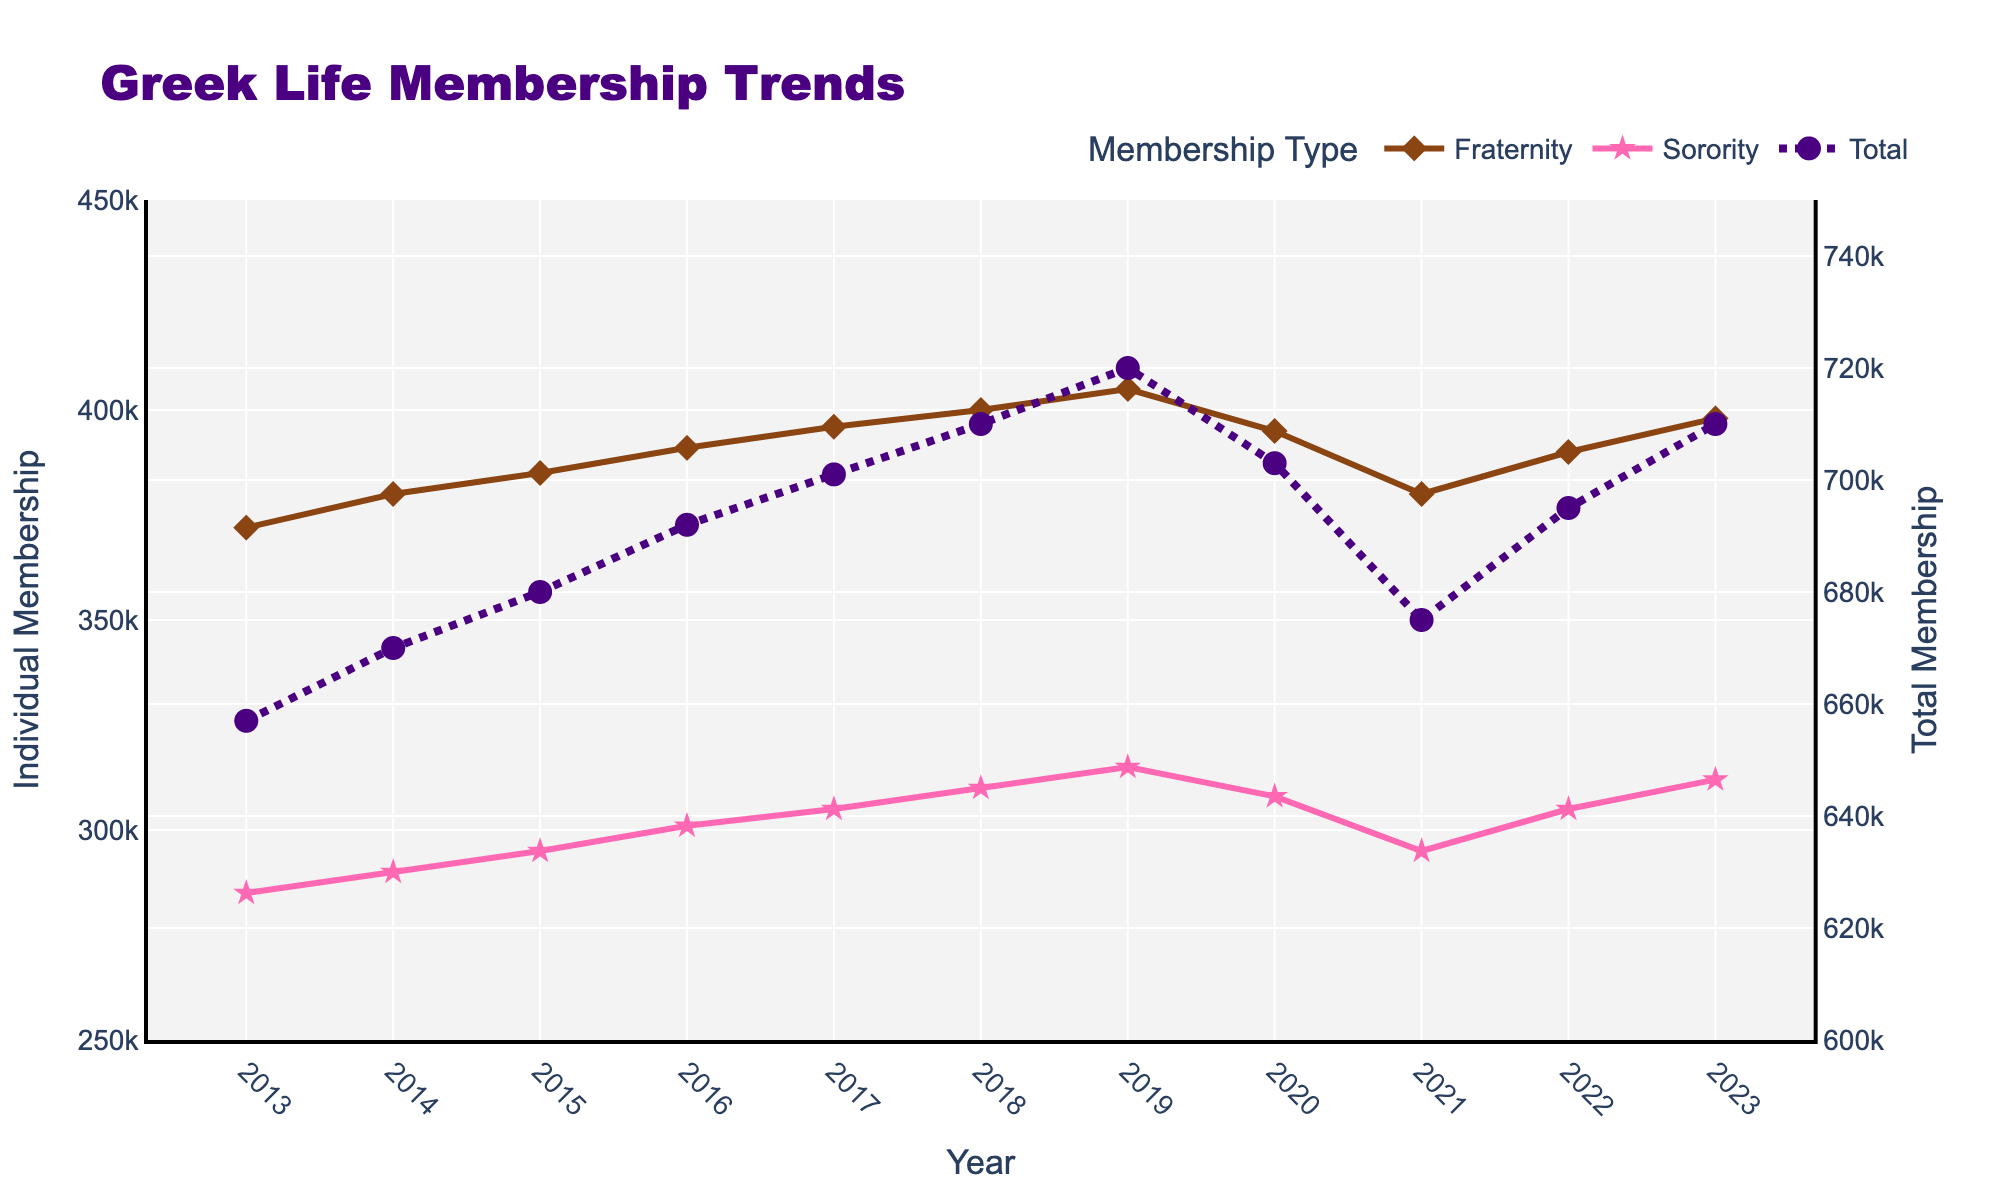What's the general trend of Total Greek Membership from 2013 to 2023? The total membership shows an overall upward trend from 2013 to 2023. Although there is a slight dip in 2020 and 2021, the trend resumes its increase.
Answer: Upward trend Did the membership numbers for Fraternities increase or decrease from 2020 to 2023? The membership numbers for Fraternities decreased from 405,000 in 2019 to 395,000 in 2020, then increased gradually to 398,000 by 2023.
Answer: Decrease then increase Between which years did Sorority Membership see the greatest increase? The Sorority Membership saw the most significant increase from 2016 to 2017, where it increased by 4,000 (from 301,000 to 305,000).
Answer: 2016-2017 By how much did the Total Greek Membership change from its highest point to the lowest within the decade? The highest Total Greek Membership was 720,000 in 2019, and the lowest was 657,000 in 2013. The difference is 720,000 - 657,000 = 63,000.
Answer: 63,000 In which year did Fraternities have the lowest membership within the past decade? Looking at the Fraternity Membership trend line, the lowest membership was in 2013, at 372,000.
Answer: 2013 How did the Sorority Membership numbers change from 2021 to 2023? Sorority Membership increased from 295,000 in 2021 to 305,000 in 2022, and then to 312,000 in 2023.
Answer: Increased Did Fraternity or Sorority Membership show more stability in the past decade? By observing the lines, Sorority Membership shows a more stable, gradual increase every year. Fraternity Membership, however, has more fluctuations, particularly around 2020 and 2021.
Answer: Sorority Membership What visual attributes help differentiate the Total Greek Membership line from the Fraternity and Sorority lines? The Total Greek Membership line is purple, thicker, and is drawn with a dot-dashed style, while the Fraternity and Sorority lines are solid brown and pink, respectively.
Answer: Color and Line Style Between 2013 and 2023, did any membership type return to a previous value after a fluctuation? Yes, the Total Greek Membership returned to 710,000 in 2023, which was the same as in 2018.
Answer: Yes 